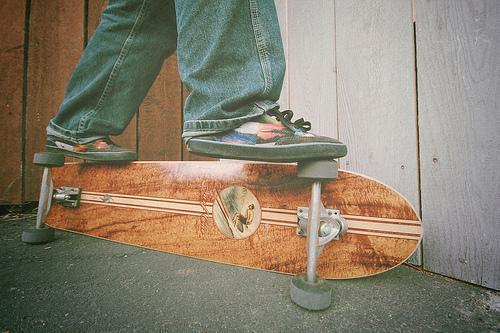How many people are there?
Give a very brief answer. 1. 